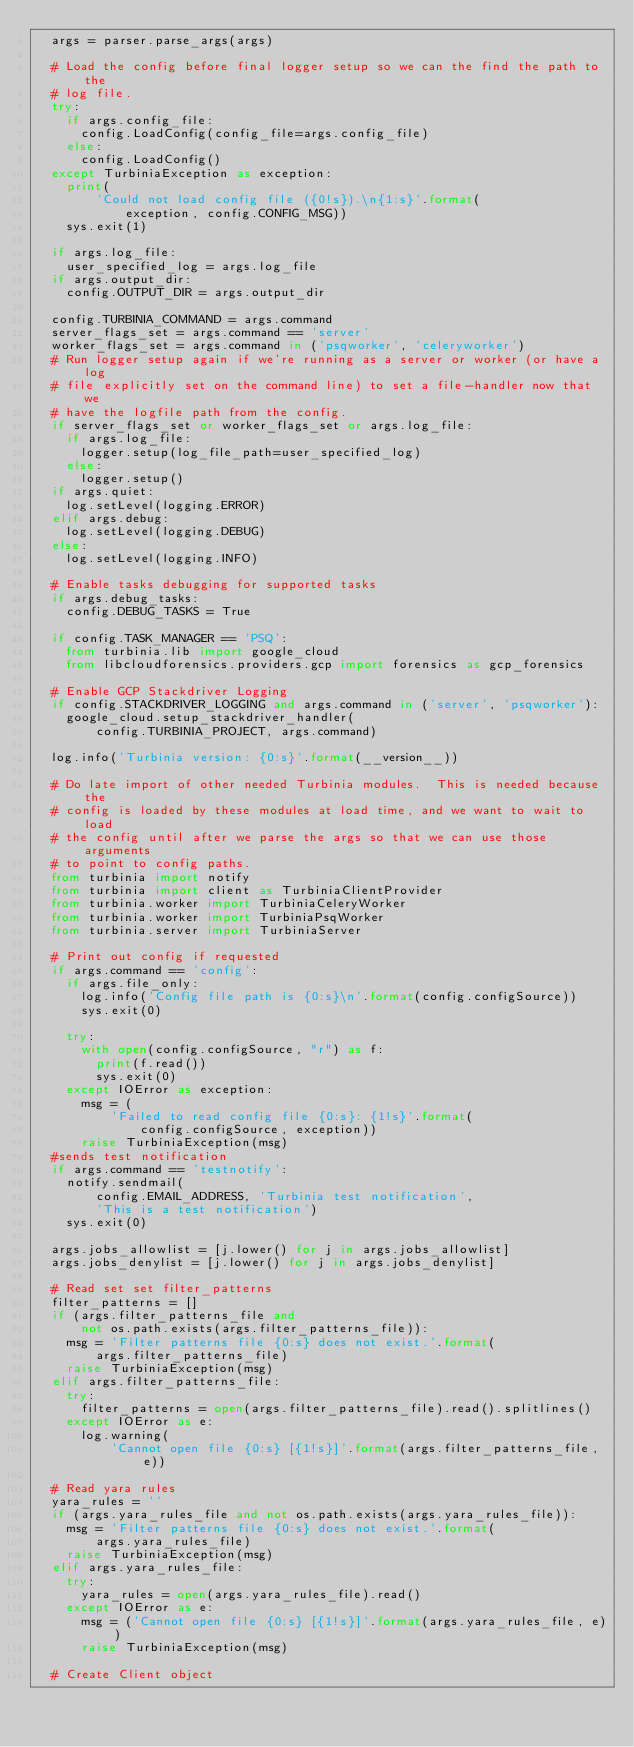<code> <loc_0><loc_0><loc_500><loc_500><_Python_>  args = parser.parse_args(args)

  # Load the config before final logger setup so we can the find the path to the
  # log file.
  try:
    if args.config_file:
      config.LoadConfig(config_file=args.config_file)
    else:
      config.LoadConfig()
  except TurbiniaException as exception:
    print(
        'Could not load config file ({0!s}).\n{1:s}'.format(
            exception, config.CONFIG_MSG))
    sys.exit(1)

  if args.log_file:
    user_specified_log = args.log_file
  if args.output_dir:
    config.OUTPUT_DIR = args.output_dir

  config.TURBINIA_COMMAND = args.command
  server_flags_set = args.command == 'server'
  worker_flags_set = args.command in ('psqworker', 'celeryworker')
  # Run logger setup again if we're running as a server or worker (or have a log
  # file explicitly set on the command line) to set a file-handler now that we
  # have the logfile path from the config.
  if server_flags_set or worker_flags_set or args.log_file:
    if args.log_file:
      logger.setup(log_file_path=user_specified_log)
    else:
      logger.setup()
  if args.quiet:
    log.setLevel(logging.ERROR)
  elif args.debug:
    log.setLevel(logging.DEBUG)
  else:
    log.setLevel(logging.INFO)

  # Enable tasks debugging for supported tasks
  if args.debug_tasks:
    config.DEBUG_TASKS = True

  if config.TASK_MANAGER == 'PSQ':
    from turbinia.lib import google_cloud
    from libcloudforensics.providers.gcp import forensics as gcp_forensics

  # Enable GCP Stackdriver Logging
  if config.STACKDRIVER_LOGGING and args.command in ('server', 'psqworker'):
    google_cloud.setup_stackdriver_handler(
        config.TURBINIA_PROJECT, args.command)

  log.info('Turbinia version: {0:s}'.format(__version__))

  # Do late import of other needed Turbinia modules.  This is needed because the
  # config is loaded by these modules at load time, and we want to wait to load
  # the config until after we parse the args so that we can use those arguments
  # to point to config paths.
  from turbinia import notify
  from turbinia import client as TurbiniaClientProvider
  from turbinia.worker import TurbiniaCeleryWorker
  from turbinia.worker import TurbiniaPsqWorker
  from turbinia.server import TurbiniaServer

  # Print out config if requested
  if args.command == 'config':
    if args.file_only:
      log.info('Config file path is {0:s}\n'.format(config.configSource))
      sys.exit(0)

    try:
      with open(config.configSource, "r") as f:
        print(f.read())
        sys.exit(0)
    except IOError as exception:
      msg = (
          'Failed to read config file {0:s}: {1!s}'.format(
              config.configSource, exception))
      raise TurbiniaException(msg)
  #sends test notification
  if args.command == 'testnotify':
    notify.sendmail(
        config.EMAIL_ADDRESS, 'Turbinia test notification',
        'This is a test notification')
    sys.exit(0)

  args.jobs_allowlist = [j.lower() for j in args.jobs_allowlist]
  args.jobs_denylist = [j.lower() for j in args.jobs_denylist]

  # Read set set filter_patterns
  filter_patterns = []
  if (args.filter_patterns_file and
      not os.path.exists(args.filter_patterns_file)):
    msg = 'Filter patterns file {0:s} does not exist.'.format(
        args.filter_patterns_file)
    raise TurbiniaException(msg)
  elif args.filter_patterns_file:
    try:
      filter_patterns = open(args.filter_patterns_file).read().splitlines()
    except IOError as e:
      log.warning(
          'Cannot open file {0:s} [{1!s}]'.format(args.filter_patterns_file, e))

  # Read yara rules
  yara_rules = ''
  if (args.yara_rules_file and not os.path.exists(args.yara_rules_file)):
    msg = 'Filter patterns file {0:s} does not exist.'.format(
        args.yara_rules_file)
    raise TurbiniaException(msg)
  elif args.yara_rules_file:
    try:
      yara_rules = open(args.yara_rules_file).read()
    except IOError as e:
      msg = ('Cannot open file {0:s} [{1!s}]'.format(args.yara_rules_file, e))
      raise TurbiniaException(msg)

  # Create Client object</code> 